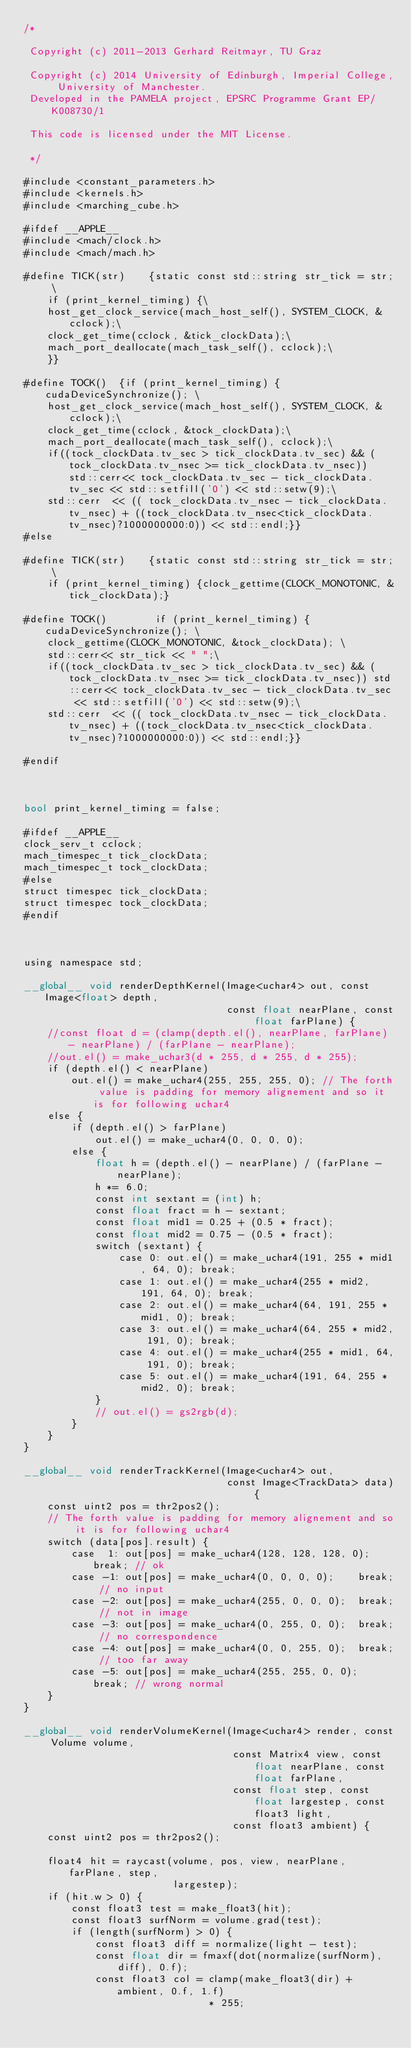<code> <loc_0><loc_0><loc_500><loc_500><_Cuda_>/*

 Copyright (c) 2011-2013 Gerhard Reitmayr, TU Graz

 Copyright (c) 2014 University of Edinburgh, Imperial College, University of Manchester.
 Developed in the PAMELA project, EPSRC Programme Grant EP/K008730/1

 This code is licensed under the MIT License.

 */

#include <constant_parameters.h>
#include <kernels.h>
#include <marching_cube.h>

#ifdef __APPLE__
#include <mach/clock.h>
#include <mach/mach.h>

#define TICK(str)    {static const std::string str_tick = str; \
    if (print_kernel_timing) {\
    host_get_clock_service(mach_host_self(), SYSTEM_CLOCK, &cclock);\
    clock_get_time(cclock, &tick_clockData);\
    mach_port_deallocate(mach_task_self(), cclock);\
    }}

#define TOCK()  {if (print_kernel_timing) {cudaDeviceSynchronize(); \
    host_get_clock_service(mach_host_self(), SYSTEM_CLOCK, &cclock);\
    clock_get_time(cclock, &tock_clockData);\
    mach_port_deallocate(mach_task_self(), cclock);\
    if((tock_clockData.tv_sec > tick_clockData.tv_sec) && (tock_clockData.tv_nsec >= tick_clockData.tv_nsec))   std::cerr<< tock_clockData.tv_sec - tick_clockData.tv_sec << std::setfill('0') << std::setw(9);\
    std::cerr  << (( tock_clockData.tv_nsec - tick_clockData.tv_nsec) + ((tock_clockData.tv_nsec<tick_clockData.tv_nsec)?1000000000:0)) << std::endl;}}
#else

#define TICK(str)    {static const std::string str_tick = str; \
    if (print_kernel_timing) {clock_gettime(CLOCK_MONOTONIC, &tick_clockData);}

#define TOCK()        if (print_kernel_timing) {cudaDeviceSynchronize(); \
    clock_gettime(CLOCK_MONOTONIC, &tock_clockData); \
    std::cerr<< str_tick << " ";\
    if((tock_clockData.tv_sec > tick_clockData.tv_sec) && (tock_clockData.tv_nsec >= tick_clockData.tv_nsec)) std::cerr<< tock_clockData.tv_sec - tick_clockData.tv_sec << std::setfill('0') << std::setw(9);\
    std::cerr  << (( tock_clockData.tv_nsec - tick_clockData.tv_nsec) + ((tock_clockData.tv_nsec<tick_clockData.tv_nsec)?1000000000:0)) << std::endl;}}

#endif



bool print_kernel_timing = false;

#ifdef __APPLE__
clock_serv_t cclock;
mach_timespec_t tick_clockData;
mach_timespec_t tock_clockData;
#else
struct timespec tick_clockData;
struct timespec tock_clockData;
#endif



using namespace std;

__global__ void renderDepthKernel(Image<uchar4> out, const Image<float> depth,
                                  const float nearPlane, const float farPlane) {
    //const float d = (clamp(depth.el(), nearPlane, farPlane) - nearPlane) / (farPlane - nearPlane);
    //out.el() = make_uchar3(d * 255, d * 255, d * 255);
    if (depth.el() < nearPlane)
        out.el() = make_uchar4(255, 255, 255, 0); // The forth value is padding for memory alignement and so it is for following uchar4
    else {
        if (depth.el() > farPlane)
            out.el() = make_uchar4(0, 0, 0, 0);
        else {
            float h = (depth.el() - nearPlane) / (farPlane - nearPlane);
            h *= 6.0;
            const int sextant = (int) h;
            const float fract = h - sextant;
            const float mid1 = 0.25 + (0.5 * fract);
            const float mid2 = 0.75 - (0.5 * fract);
            switch (sextant) {
                case 0: out.el() = make_uchar4(191, 255 * mid1, 64, 0); break;
                case 1: out.el() = make_uchar4(255 * mid2, 191, 64, 0); break;
                case 2: out.el() = make_uchar4(64, 191, 255 * mid1, 0); break;
                case 3: out.el() = make_uchar4(64, 255 * mid2, 191, 0); break;
                case 4: out.el() = make_uchar4(255 * mid1, 64, 191, 0); break;
                case 5: out.el() = make_uchar4(191, 64, 255 * mid2, 0); break;
            }
            // out.el() = gs2rgb(d);
        }
    }
}

__global__ void renderTrackKernel(Image<uchar4> out,
                                  const Image<TrackData> data) {
    const uint2 pos = thr2pos2();
    // The forth value is padding for memory alignement and so it is for following uchar4
    switch (data[pos].result) {
        case  1: out[pos] = make_uchar4(128, 128, 128, 0);	break; // ok
        case -1: out[pos] = make_uchar4(0, 0, 0, 0);	break; // no input
        case -2: out[pos] = make_uchar4(255, 0, 0, 0);	break; // not in image
        case -3: out[pos] = make_uchar4(0, 255, 0, 0);	break; // no correspondence
        case -4: out[pos] = make_uchar4(0, 0, 255, 0);	break; // too far away
        case -5: out[pos] = make_uchar4(255, 255, 0, 0);	break; // wrong normal
    }
}

__global__ void renderVolumeKernel(Image<uchar4> render, const Volume volume,
                                   const Matrix4 view, const float nearPlane, const float farPlane,
                                   const float step, const float largestep, const float3 light,
                                   const float3 ambient) {
    const uint2 pos = thr2pos2();

    float4 hit = raycast(volume, pos, view, nearPlane, farPlane, step,
                         largestep);
    if (hit.w > 0) {
        const float3 test = make_float3(hit);
        const float3 surfNorm = volume.grad(test);
        if (length(surfNorm) > 0) {
            const float3 diff = normalize(light - test);
            const float dir = fmaxf(dot(normalize(surfNorm), diff), 0.f);
            const float3 col = clamp(make_float3(dir) + ambient, 0.f, 1.f)
                               * 255;</code> 